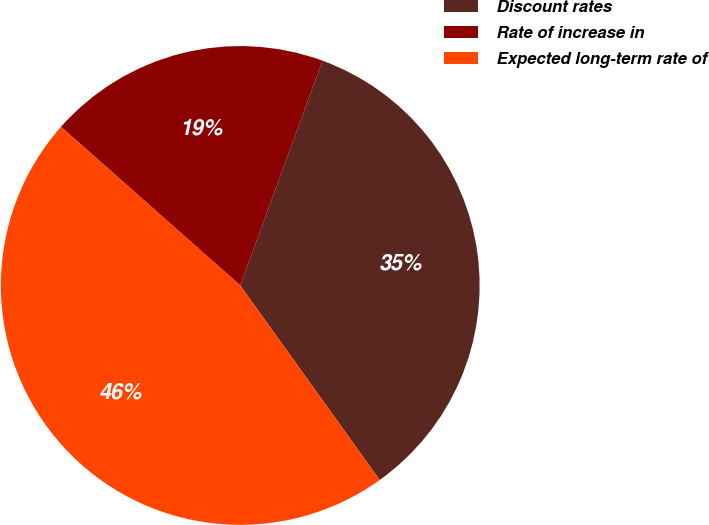Convert chart to OTSL. <chart><loc_0><loc_0><loc_500><loc_500><pie_chart><fcel>Discount rates<fcel>Rate of increase in<fcel>Expected long-term rate of<nl><fcel>34.52%<fcel>19.05%<fcel>46.43%<nl></chart> 